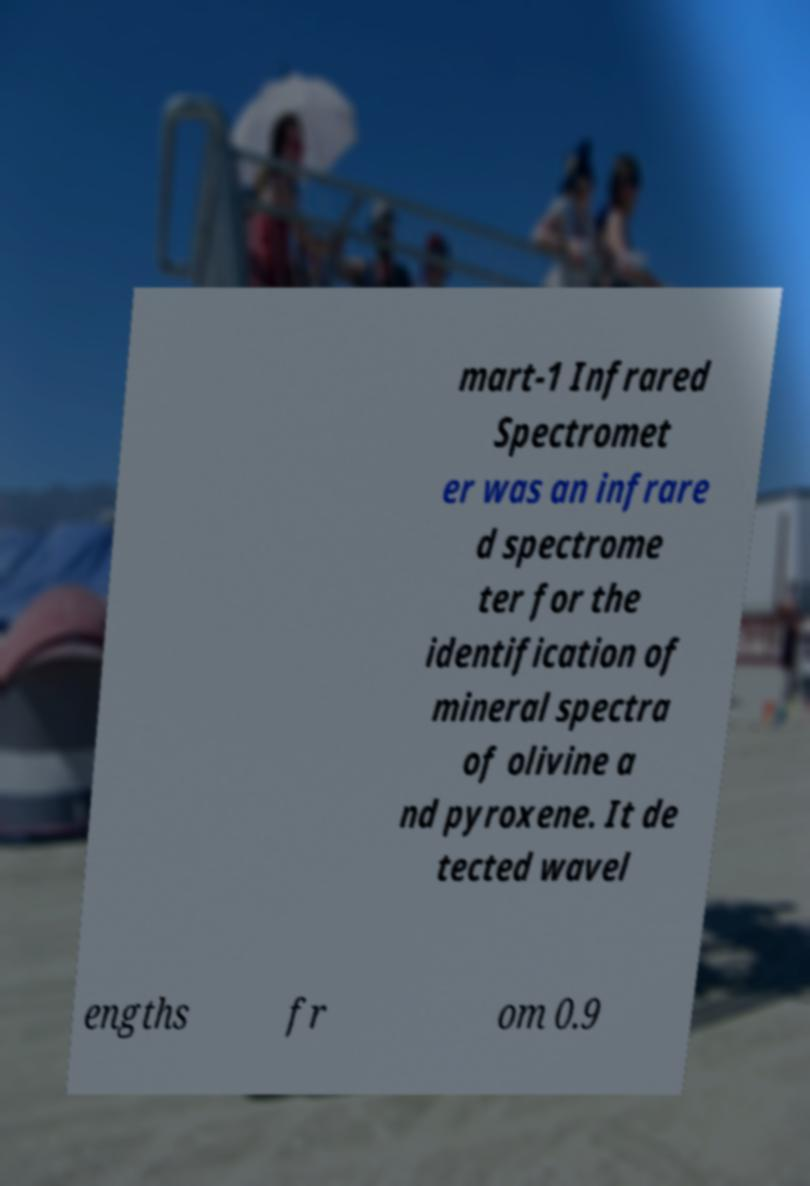I need the written content from this picture converted into text. Can you do that? mart-1 Infrared Spectromet er was an infrare d spectrome ter for the identification of mineral spectra of olivine a nd pyroxene. It de tected wavel engths fr om 0.9 